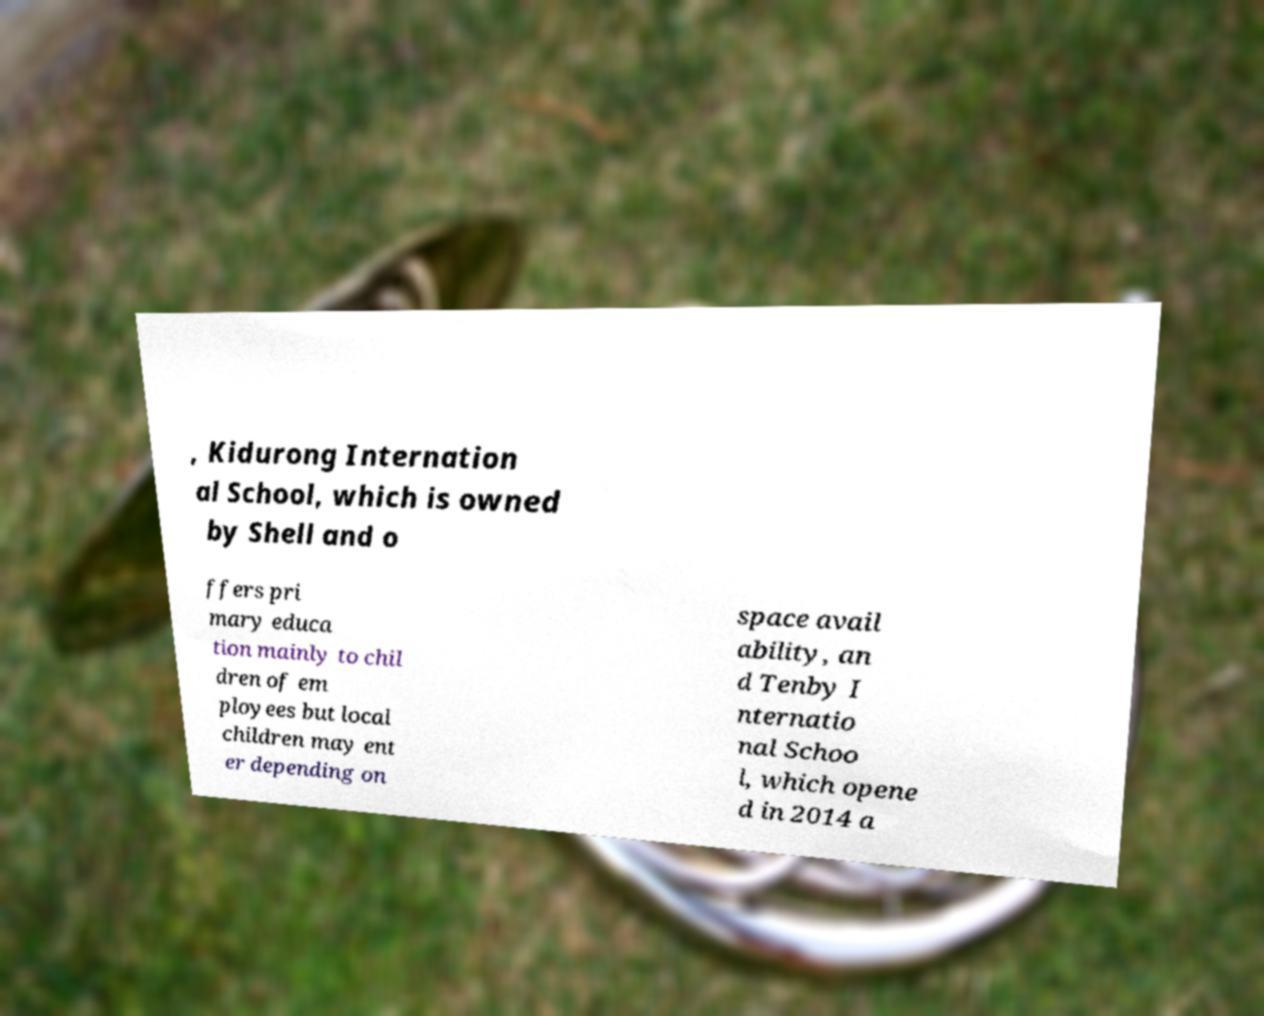Could you assist in decoding the text presented in this image and type it out clearly? , Kidurong Internation al School, which is owned by Shell and o ffers pri mary educa tion mainly to chil dren of em ployees but local children may ent er depending on space avail ability, an d Tenby I nternatio nal Schoo l, which opene d in 2014 a 